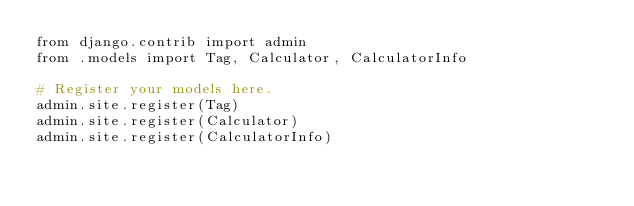<code> <loc_0><loc_0><loc_500><loc_500><_Python_>from django.contrib import admin
from .models import Tag, Calculator, CalculatorInfo

# Register your models here.
admin.site.register(Tag)
admin.site.register(Calculator)
admin.site.register(CalculatorInfo)
</code> 